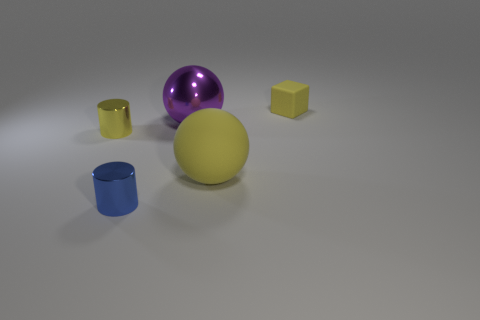Add 4 purple metal objects. How many objects exist? 9 Subtract all balls. How many objects are left? 3 Subtract all red cubes. Subtract all red balls. How many cubes are left? 1 Subtract all brown cylinders. Subtract all big yellow spheres. How many objects are left? 4 Add 3 large purple metallic objects. How many large purple metallic objects are left? 4 Add 2 big blue things. How many big blue things exist? 2 Subtract 0 brown cylinders. How many objects are left? 5 